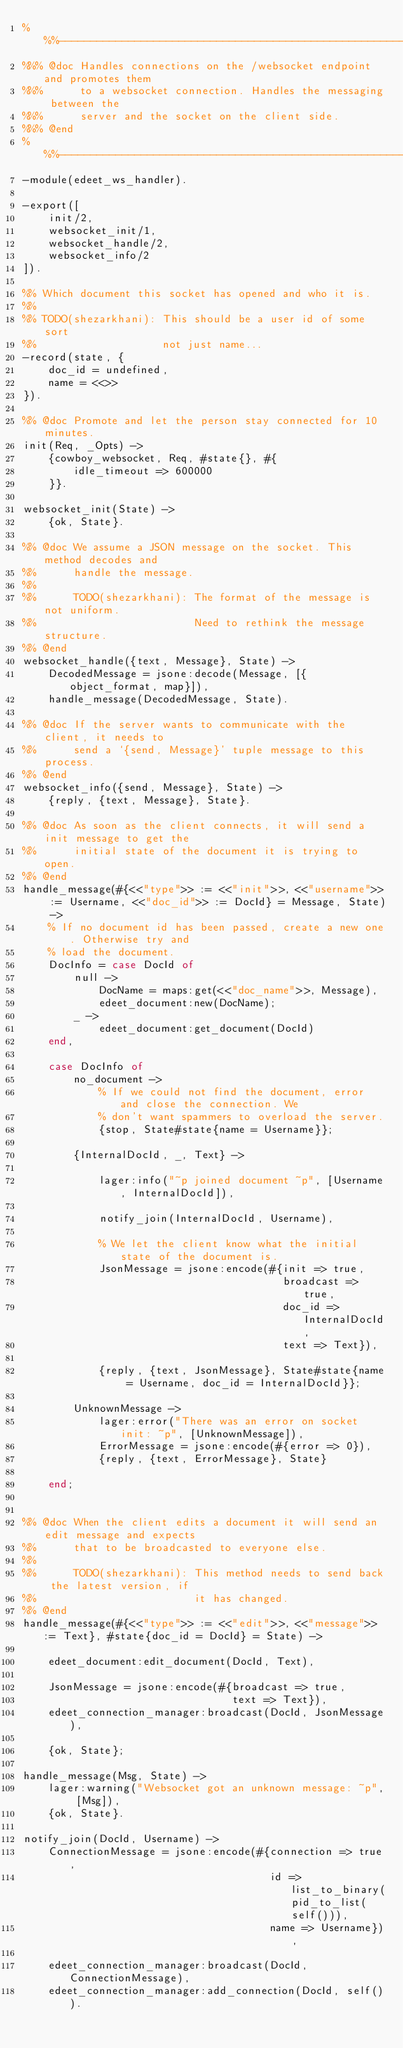<code> <loc_0><loc_0><loc_500><loc_500><_Erlang_>%%%-------------------------------------------------------------------
%%% @doc Handles connections on the /websocket endpoint and promotes them
%%%      to a websocket connection. Handles the messaging between the
%%%      server and the socket on the client side.
%%% @end
%%%-------------------------------------------------------------------
-module(edeet_ws_handler).

-export([
    init/2,
    websocket_init/1,
    websocket_handle/2,
    websocket_info/2
]).

%% Which document this socket has opened and who it is.
%%
%% TODO(shezarkhani): This should be a user id of some sort
%%                    not just name...
-record(state, {
    doc_id = undefined,
    name = <<>>
}).

%% @doc Promote and let the person stay connected for 10 minutes.
init(Req, _Opts) ->
    {cowboy_websocket, Req, #state{}, #{
        idle_timeout => 600000
    }}.

websocket_init(State) ->
    {ok, State}.

%% @doc We assume a JSON message on the socket. This method decodes and
%%      handle the message.
%%
%%      TODO(shezarkhani): The format of the message is not uniform.
%%                         Need to rethink the message structure.
%% @end
websocket_handle({text, Message}, State) ->
    DecodedMessage = jsone:decode(Message, [{object_format, map}]),
    handle_message(DecodedMessage, State).

%% @doc If the server wants to communicate with the client, it needs to
%%      send a `{send, Message}' tuple message to this process.
%% @end
websocket_info({send, Message}, State) ->
    {reply, {text, Message}, State}.

%% @doc As soon as the client connects, it will send a init message to get the
%%      initial state of the document it is trying to open.
%% @end
handle_message(#{<<"type">> := <<"init">>, <<"username">> := Username, <<"doc_id">> := DocId} = Message, State) ->
    % If no document id has been passed, create a new one. Otherwise try and
    % load the document.
    DocInfo = case DocId of
        null ->
            DocName = maps:get(<<"doc_name">>, Message),
            edeet_document:new(DocName);
        _ ->
            edeet_document:get_document(DocId)
    end,

    case DocInfo of
        no_document ->
            % If we could not find the document, error and close the connection. We
            % don't want spammers to overload the server.
            {stop, State#state{name = Username}};

        {InternalDocId, _, Text} ->

            lager:info("~p joined document ~p", [Username, InternalDocId]),

            notify_join(InternalDocId, Username),

            % We let the client know what the initial state of the document is.
            JsonMessage = jsone:encode(#{init => true,
                                         broadcast => true,
                                         doc_id => InternalDocId,
                                         text => Text}),

            {reply, {text, JsonMessage}, State#state{name = Username, doc_id = InternalDocId}};

        UnknownMessage ->
            lager:error("There was an error on socket init: ~p", [UnknownMessage]),
            ErrorMessage = jsone:encode(#{error => 0}),
            {reply, {text, ErrorMessage}, State}

    end;


%% @doc When the client edits a document it will send an edit message and expects
%%      that to be broadcasted to everyone else.
%%
%%      TODO(shezarkhani): This method needs to send back the latest version, if
%%                         it has changed.
%% @end
handle_message(#{<<"type">> := <<"edit">>, <<"message">> := Text}, #state{doc_id = DocId} = State) ->

    edeet_document:edit_document(DocId, Text),

    JsonMessage = jsone:encode(#{broadcast => true,
                                 text => Text}),
    edeet_connection_manager:broadcast(DocId, JsonMessage),

    {ok, State};

handle_message(Msg, State) ->
    lager:warning("Websocket got an unknown message: ~p", [Msg]),
    {ok, State}.

notify_join(DocId, Username) ->
    ConnectionMessage = jsone:encode(#{connection => true,
                                       id => list_to_binary(pid_to_list(self())),
                                       name => Username}),

    edeet_connection_manager:broadcast(DocId, ConnectionMessage),
    edeet_connection_manager:add_connection(DocId, self()).</code> 